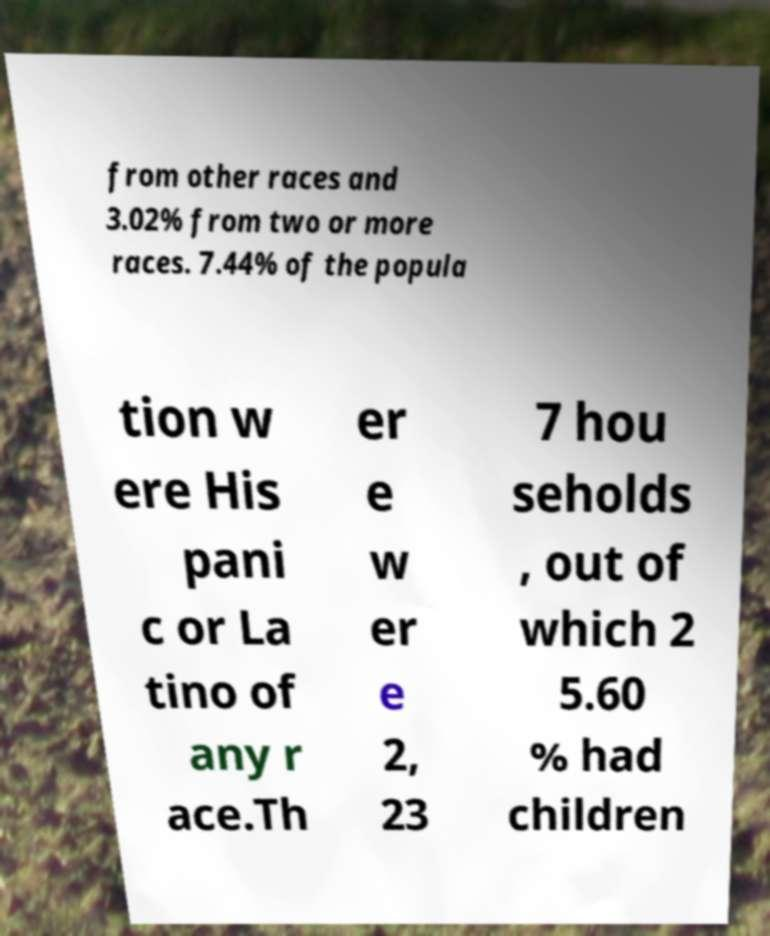Can you accurately transcribe the text from the provided image for me? from other races and 3.02% from two or more races. 7.44% of the popula tion w ere His pani c or La tino of any r ace.Th er e w er e 2, 23 7 hou seholds , out of which 2 5.60 % had children 